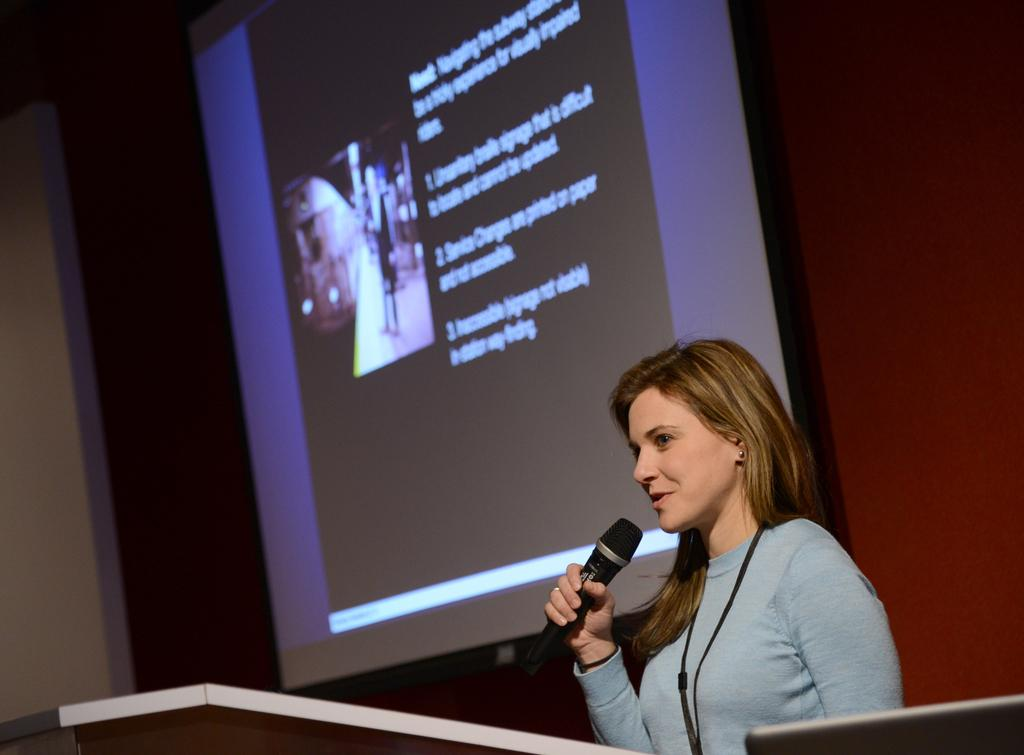Who is the main subject in the image? There is a woman in the image. What is the woman holding in her hand? The woman is holding a microphone in her hand. What is the woman doing in the image? The woman is talking. What can be seen in the background of the image? There is a screen with slides and a wall in the background of the image. What type of pleasure can be seen on the woman's face in the image? There is no indication of pleasure on the woman's face in the image; she is simply talking while holding a microphone. 